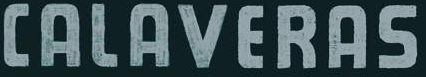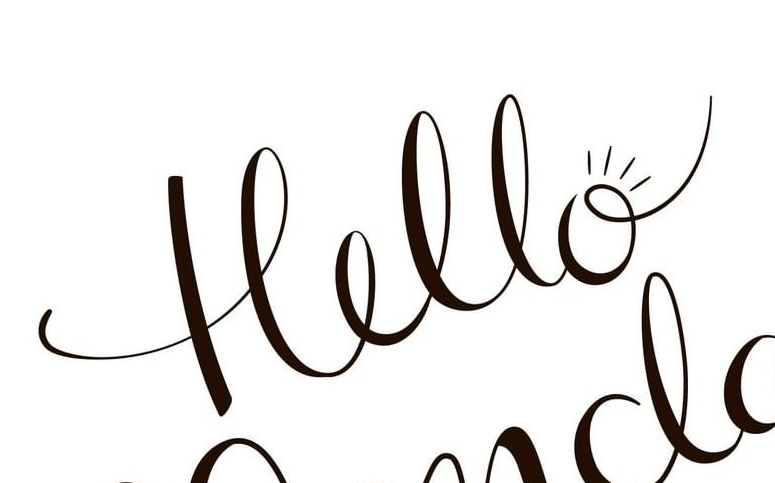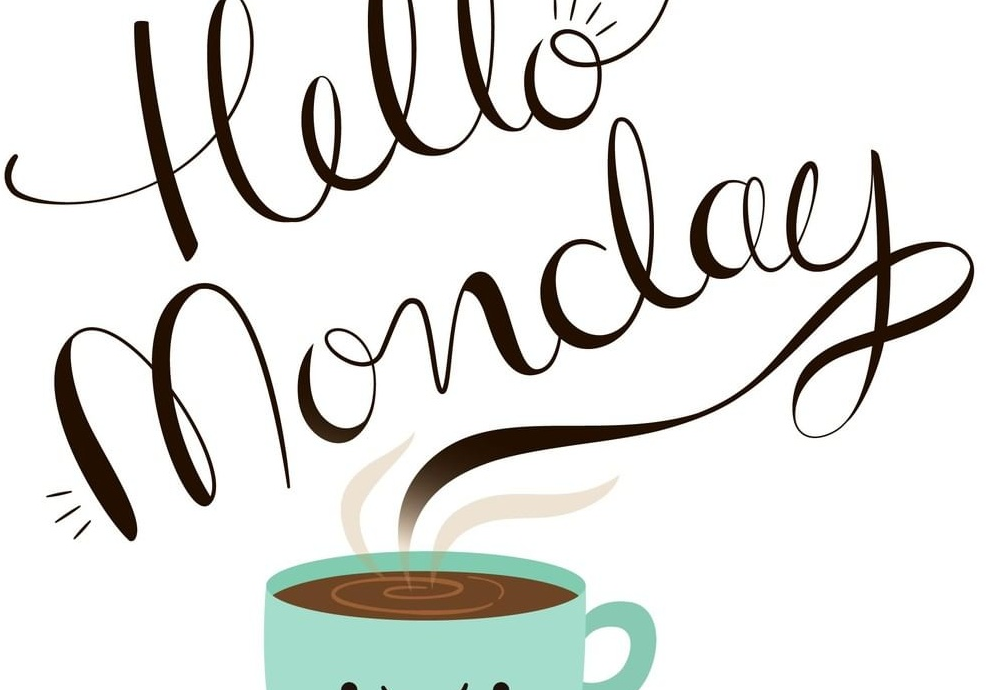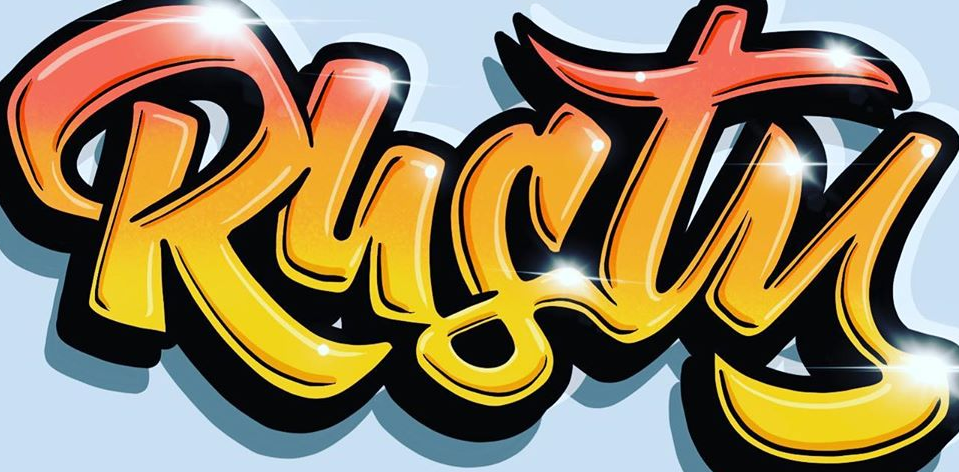Read the text from these images in sequence, separated by a semicolon. CALAVERAS; Hello; Monday; Rusty 